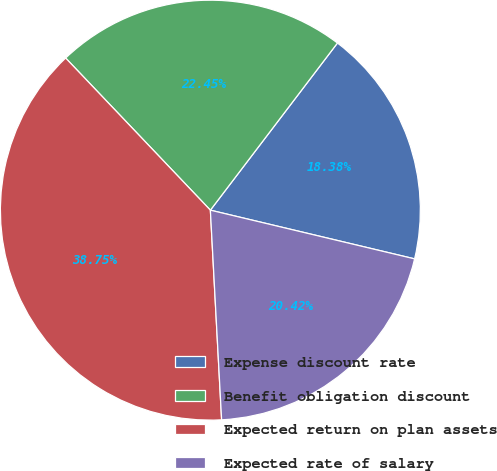Convert chart. <chart><loc_0><loc_0><loc_500><loc_500><pie_chart><fcel>Expense discount rate<fcel>Benefit obligation discount<fcel>Expected return on plan assets<fcel>Expected rate of salary<nl><fcel>18.38%<fcel>22.45%<fcel>38.75%<fcel>20.42%<nl></chart> 